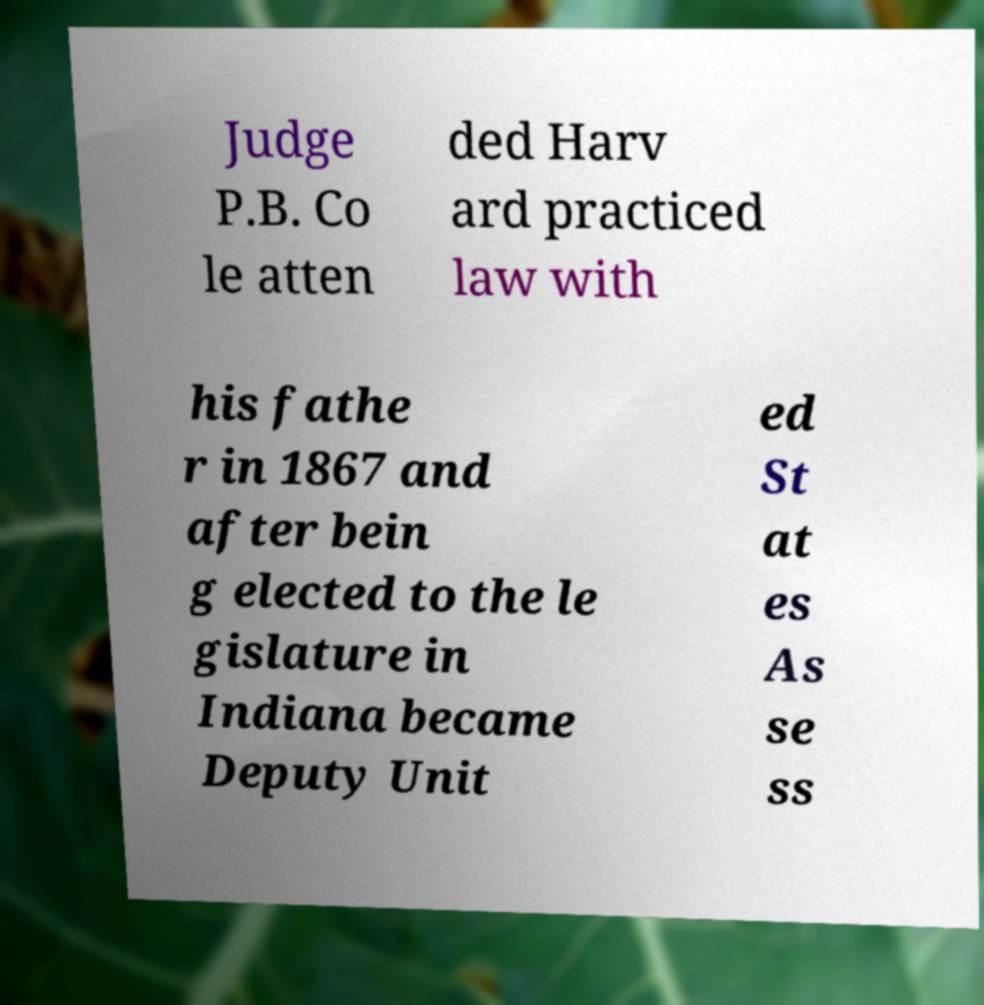Please read and relay the text visible in this image. What does it say? Judge P.B. Co le atten ded Harv ard practiced law with his fathe r in 1867 and after bein g elected to the le gislature in Indiana became Deputy Unit ed St at es As se ss 